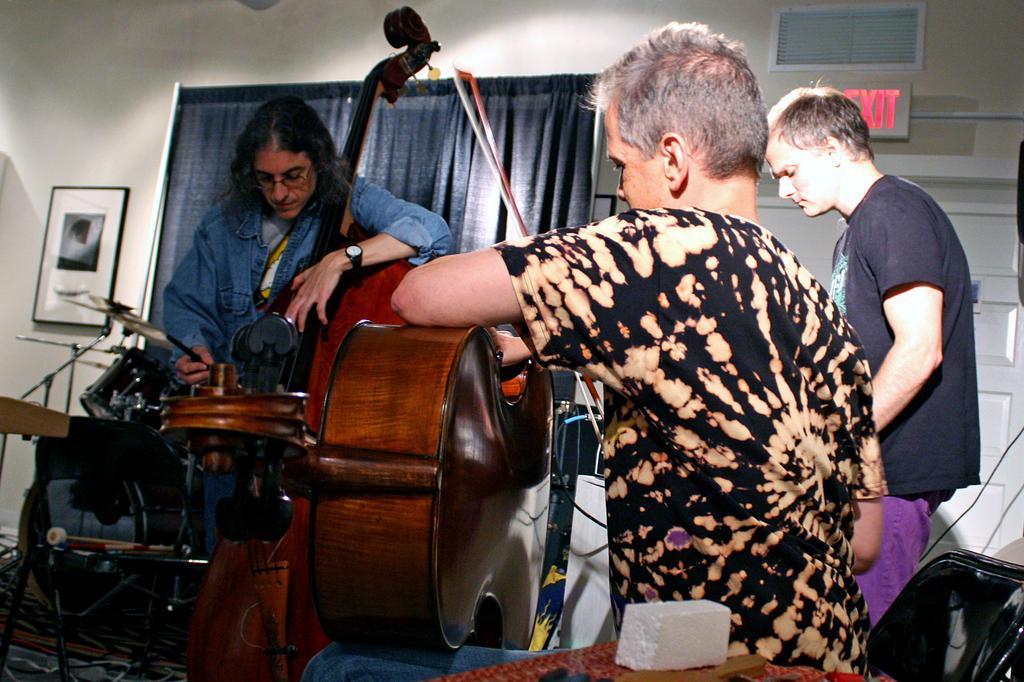Could you give a brief overview of what you see in this image? In this image i can see a group of people are standing and playing guitar in front of a microphone. I can also see there is a curtain and a photo on a wall. 